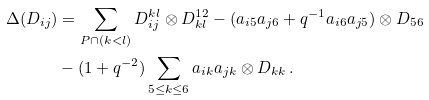Convert formula to latex. <formula><loc_0><loc_0><loc_500><loc_500>\Delta ( D _ { i j } ) & = \sum _ { P \cap ( k < l ) } D _ { i j } ^ { k l } \otimes D _ { k l } ^ { 1 2 } - ( a _ { i 5 } a _ { j 6 } + q ^ { - 1 } a _ { i 6 } a _ { j 5 } ) \otimes D _ { 5 6 } \\ & - ( 1 + q ^ { - 2 } ) \sum _ { 5 \leq k \leq 6 } a _ { i k } a _ { j k } \otimes D _ { k k } \, .</formula> 